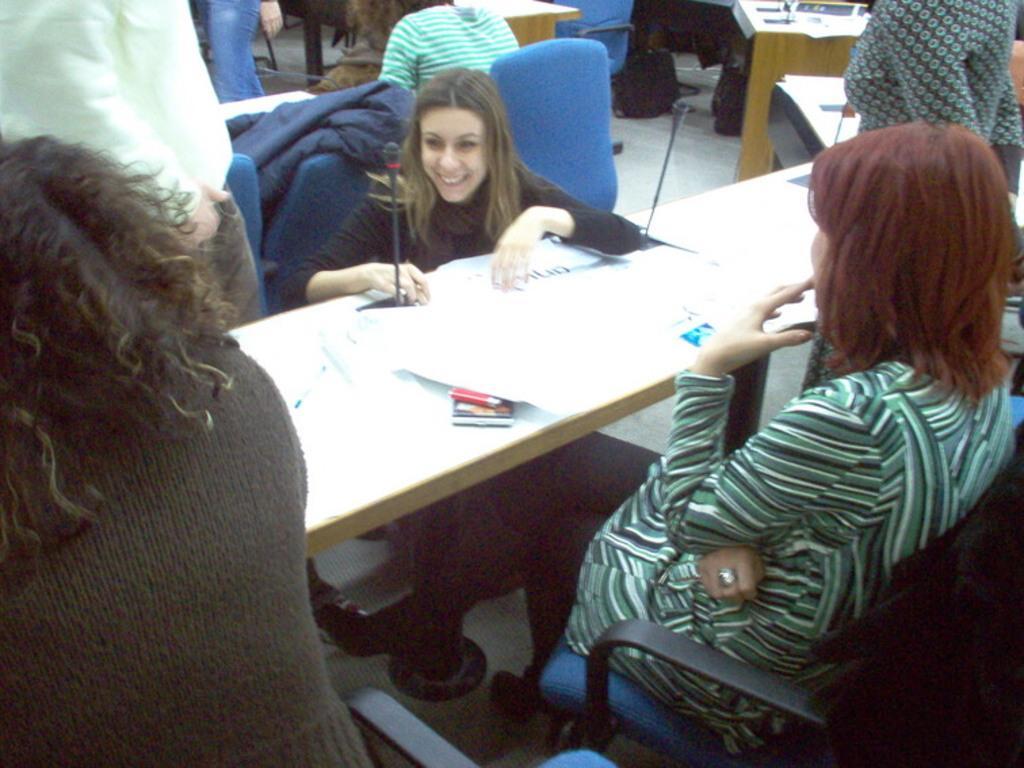Describe this image in one or two sentences. In this picture we can see persons sitting on chairs in front of a table and on the table we can see mikes, paper. This is a floor and on the floor we can see bags and few persons standing. 